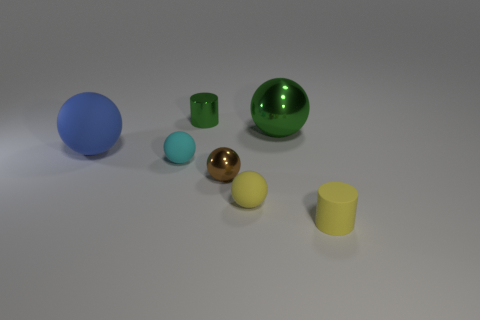Subtract all blue balls. How many balls are left? 4 Subtract all yellow spheres. How many spheres are left? 4 Subtract all blue spheres. Subtract all yellow cylinders. How many spheres are left? 4 Add 3 brown cylinders. How many objects exist? 10 Subtract all cylinders. How many objects are left? 5 Add 6 blue rubber things. How many blue rubber things exist? 7 Subtract 1 green balls. How many objects are left? 6 Subtract all large red cylinders. Subtract all small cylinders. How many objects are left? 5 Add 2 brown things. How many brown things are left? 3 